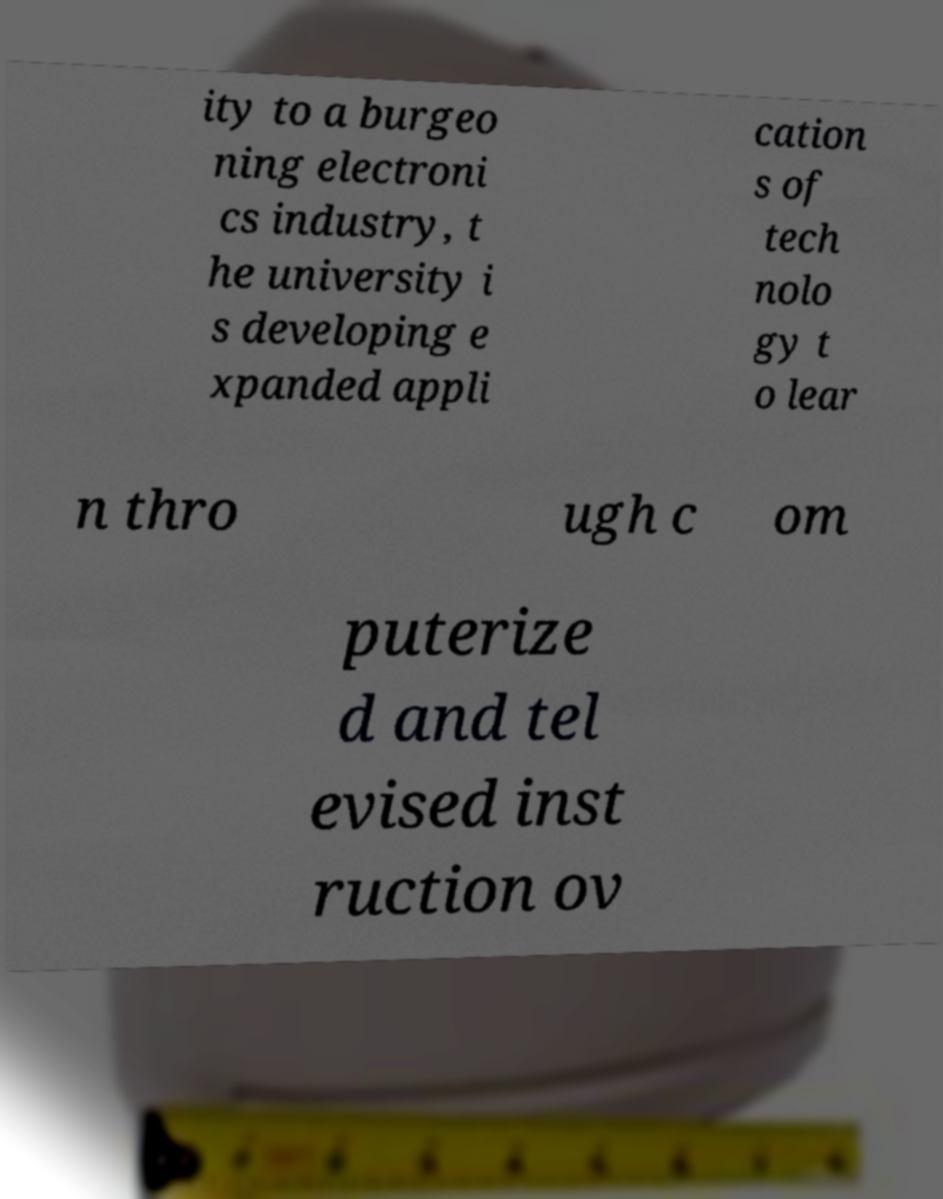I need the written content from this picture converted into text. Can you do that? ity to a burgeo ning electroni cs industry, t he university i s developing e xpanded appli cation s of tech nolo gy t o lear n thro ugh c om puterize d and tel evised inst ruction ov 